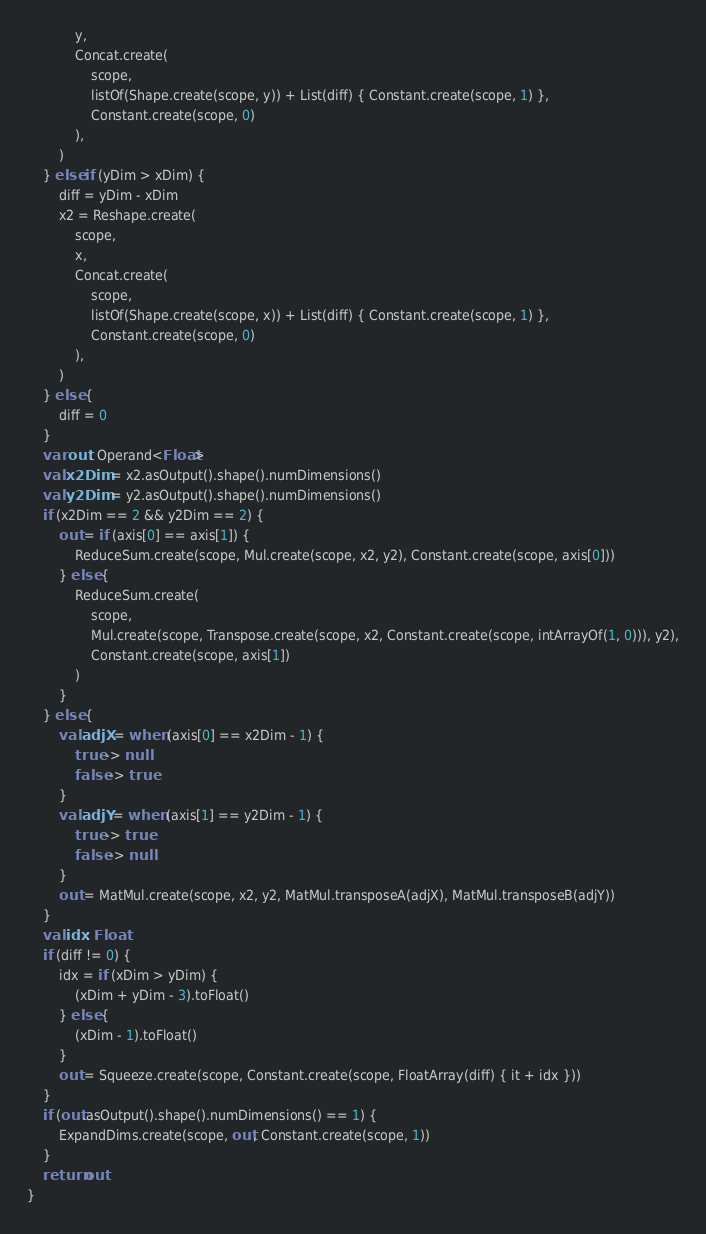Convert code to text. <code><loc_0><loc_0><loc_500><loc_500><_Kotlin_>            y,
            Concat.create(
                scope,
                listOf(Shape.create(scope, y)) + List(diff) { Constant.create(scope, 1) },
                Constant.create(scope, 0)
            ),
        )
    } else if (yDim > xDim) {
        diff = yDim - xDim
        x2 = Reshape.create(
            scope,
            x,
            Concat.create(
                scope,
                listOf(Shape.create(scope, x)) + List(diff) { Constant.create(scope, 1) },
                Constant.create(scope, 0)
            ),
        )
    } else {
        diff = 0
    }
    var out: Operand<Float>
    val x2Dim = x2.asOutput().shape().numDimensions()
    val y2Dim = y2.asOutput().shape().numDimensions()
    if (x2Dim == 2 && y2Dim == 2) {
        out = if (axis[0] == axis[1]) {
            ReduceSum.create(scope, Mul.create(scope, x2, y2), Constant.create(scope, axis[0]))
        } else {
            ReduceSum.create(
                scope,
                Mul.create(scope, Transpose.create(scope, x2, Constant.create(scope, intArrayOf(1, 0))), y2),
                Constant.create(scope, axis[1])
            )
        }
    } else {
        val adjX = when (axis[0] == x2Dim - 1) {
            true -> null
            false -> true
        }
        val adjY = when (axis[1] == y2Dim - 1) {
            true -> true
            false -> null
        }
        out = MatMul.create(scope, x2, y2, MatMul.transposeA(adjX), MatMul.transposeB(adjY))
    }
    val idx: Float
    if (diff != 0) {
        idx = if (xDim > yDim) {
            (xDim + yDim - 3).toFloat()
        } else {
            (xDim - 1).toFloat()
        }
        out = Squeeze.create(scope, Constant.create(scope, FloatArray(diff) { it + idx }))
    }
    if (out.asOutput().shape().numDimensions() == 1) {
        ExpandDims.create(scope, out, Constant.create(scope, 1))
    }
    return out
}


</code> 